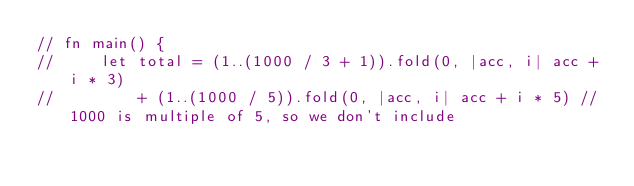Convert code to text. <code><loc_0><loc_0><loc_500><loc_500><_Rust_>// fn main() {
//     let total = (1..(1000 / 3 + 1)).fold(0, |acc, i| acc + i * 3)
//         + (1..(1000 / 5)).fold(0, |acc, i| acc + i * 5) // 1000 is multiple of 5, so we don't include</code> 